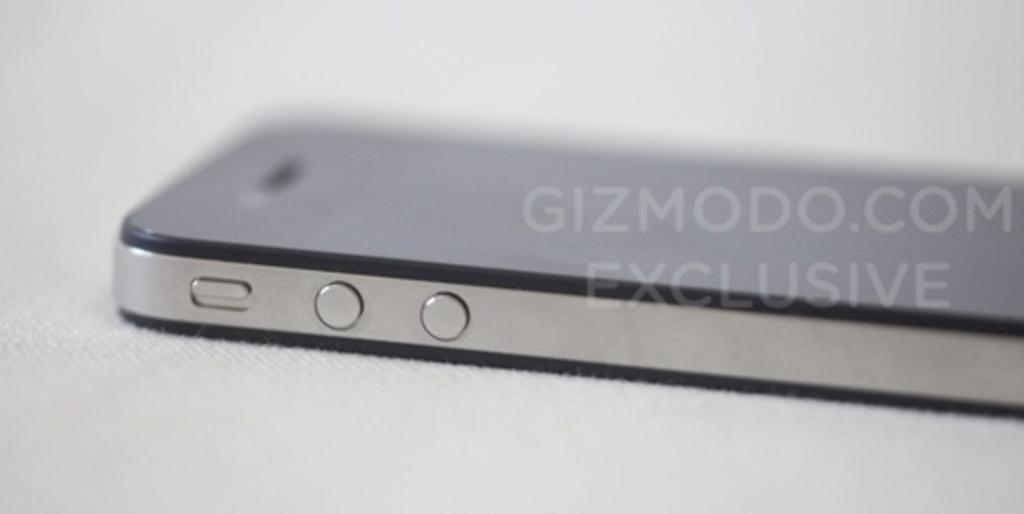<image>
Create a compact narrative representing the image presented. A cell phone face down on a surface which is a gizmodo.com exclusive 